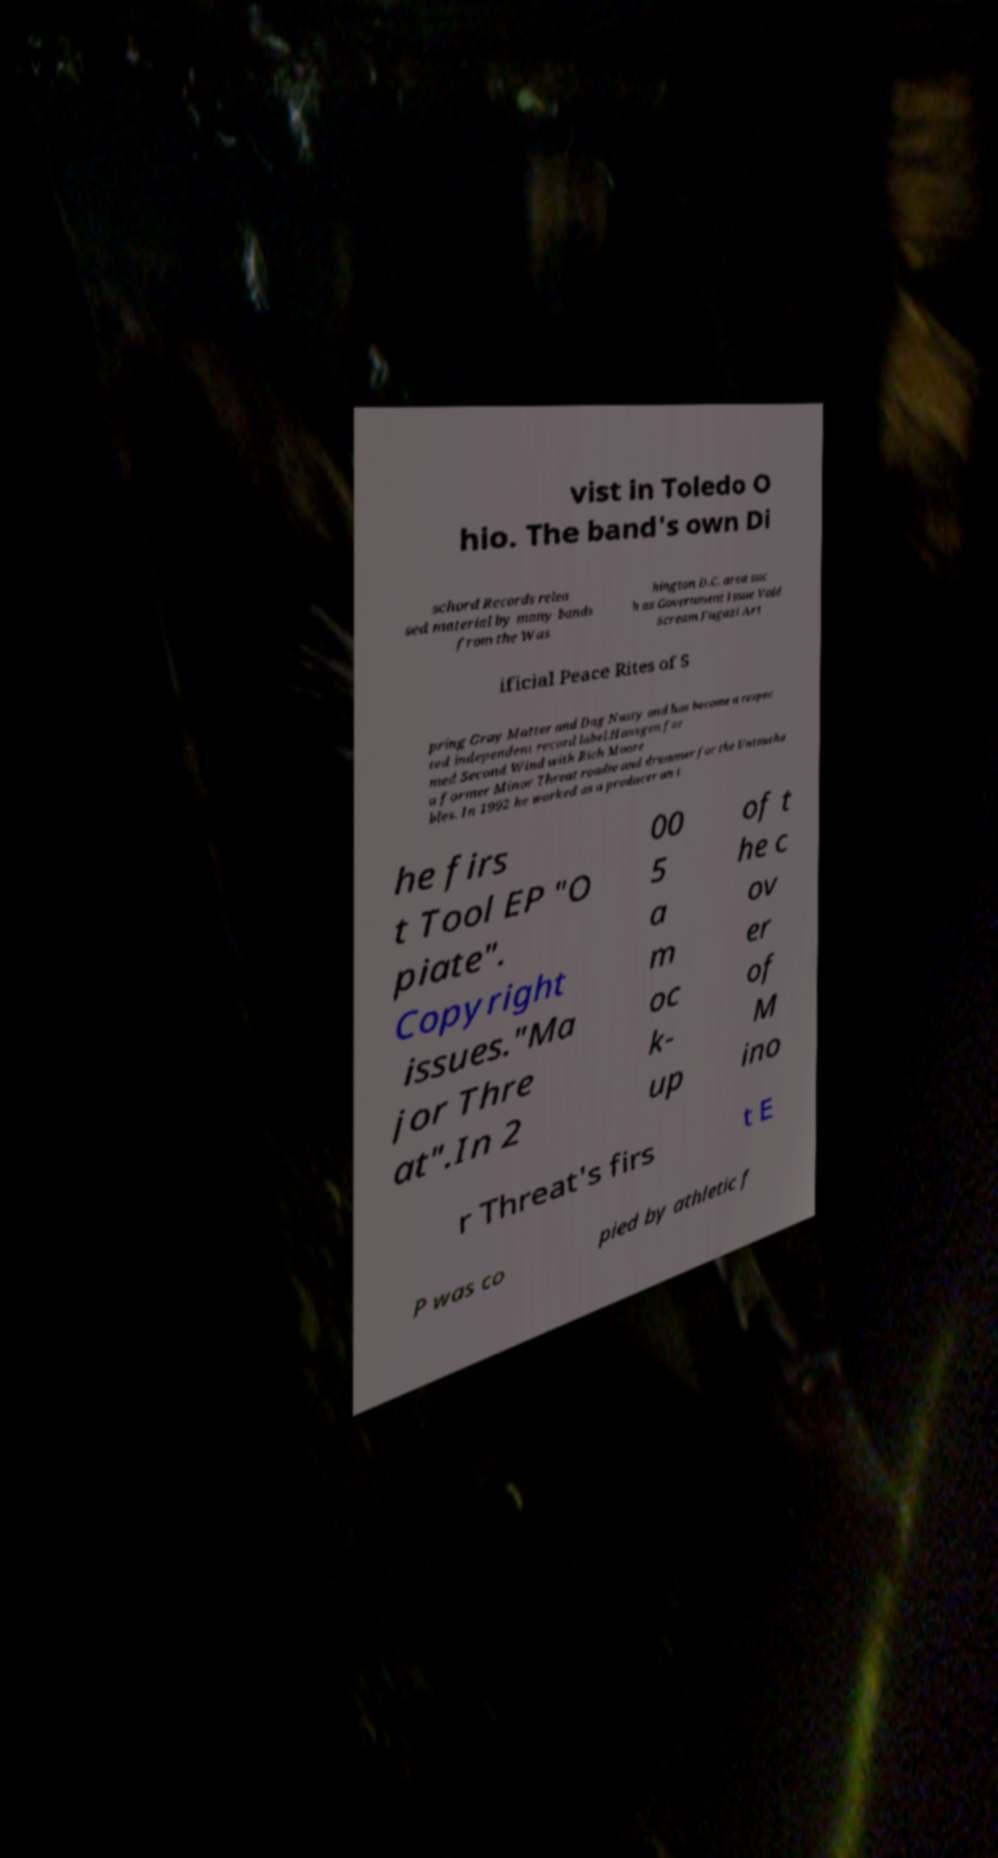Please identify and transcribe the text found in this image. vist in Toledo O hio. The band's own Di schord Records relea sed material by many bands from the Was hington D.C. area suc h as Government Issue Void Scream Fugazi Art ificial Peace Rites of S pring Gray Matter and Dag Nasty and has become a respec ted independent record label.Hansgen for med Second Wind with Rich Moore a former Minor Threat roadie and drummer for the Untoucha bles. In 1992 he worked as a producer on t he firs t Tool EP "O piate". Copyright issues."Ma jor Thre at".In 2 00 5 a m oc k- up of t he c ov er of M ino r Threat's firs t E P was co pied by athletic f 